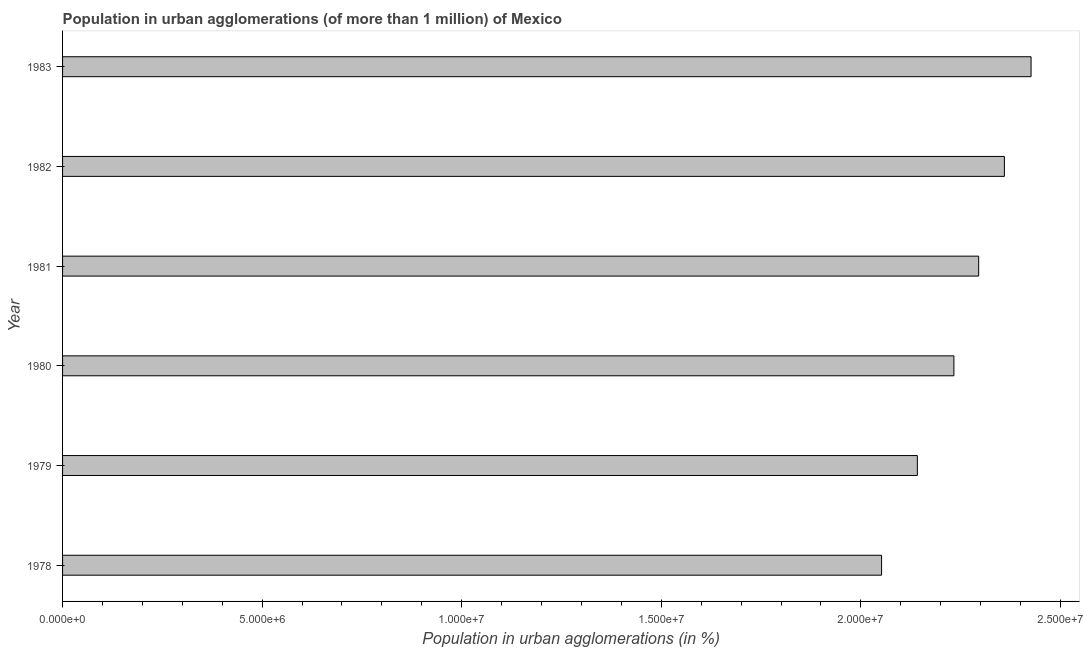Does the graph contain grids?
Make the answer very short. No. What is the title of the graph?
Your answer should be compact. Population in urban agglomerations (of more than 1 million) of Mexico. What is the label or title of the X-axis?
Your response must be concise. Population in urban agglomerations (in %). What is the population in urban agglomerations in 1978?
Your answer should be very brief. 2.05e+07. Across all years, what is the maximum population in urban agglomerations?
Give a very brief answer. 2.43e+07. Across all years, what is the minimum population in urban agglomerations?
Offer a very short reply. 2.05e+07. In which year was the population in urban agglomerations maximum?
Offer a very short reply. 1983. In which year was the population in urban agglomerations minimum?
Your answer should be compact. 1978. What is the sum of the population in urban agglomerations?
Keep it short and to the point. 1.35e+08. What is the difference between the population in urban agglomerations in 1979 and 1983?
Your answer should be compact. -2.85e+06. What is the average population in urban agglomerations per year?
Your answer should be very brief. 2.25e+07. What is the median population in urban agglomerations?
Provide a succinct answer. 2.26e+07. In how many years, is the population in urban agglomerations greater than 17000000 %?
Offer a terse response. 6. Do a majority of the years between 1983 and 1981 (inclusive) have population in urban agglomerations greater than 1000000 %?
Provide a short and direct response. Yes. What is the ratio of the population in urban agglomerations in 1981 to that in 1982?
Keep it short and to the point. 0.97. Is the difference between the population in urban agglomerations in 1978 and 1980 greater than the difference between any two years?
Ensure brevity in your answer.  No. What is the difference between the highest and the second highest population in urban agglomerations?
Your response must be concise. 6.68e+05. What is the difference between the highest and the lowest population in urban agglomerations?
Ensure brevity in your answer.  3.75e+06. How many bars are there?
Your answer should be compact. 6. Are all the bars in the graph horizontal?
Keep it short and to the point. Yes. How many years are there in the graph?
Provide a succinct answer. 6. What is the difference between two consecutive major ticks on the X-axis?
Your answer should be very brief. 5.00e+06. What is the Population in urban agglomerations (in %) of 1978?
Offer a terse response. 2.05e+07. What is the Population in urban agglomerations (in %) of 1979?
Your answer should be very brief. 2.14e+07. What is the Population in urban agglomerations (in %) in 1980?
Provide a short and direct response. 2.23e+07. What is the Population in urban agglomerations (in %) of 1981?
Make the answer very short. 2.30e+07. What is the Population in urban agglomerations (in %) of 1982?
Your answer should be compact. 2.36e+07. What is the Population in urban agglomerations (in %) of 1983?
Your response must be concise. 2.43e+07. What is the difference between the Population in urban agglomerations (in %) in 1978 and 1979?
Make the answer very short. -8.96e+05. What is the difference between the Population in urban agglomerations (in %) in 1978 and 1980?
Give a very brief answer. -1.81e+06. What is the difference between the Population in urban agglomerations (in %) in 1978 and 1981?
Offer a very short reply. -2.43e+06. What is the difference between the Population in urban agglomerations (in %) in 1978 and 1982?
Offer a very short reply. -3.08e+06. What is the difference between the Population in urban agglomerations (in %) in 1978 and 1983?
Your answer should be very brief. -3.75e+06. What is the difference between the Population in urban agglomerations (in %) in 1979 and 1980?
Provide a short and direct response. -9.15e+05. What is the difference between the Population in urban agglomerations (in %) in 1979 and 1981?
Your answer should be compact. -1.54e+06. What is the difference between the Population in urban agglomerations (in %) in 1979 and 1982?
Your answer should be compact. -2.18e+06. What is the difference between the Population in urban agglomerations (in %) in 1979 and 1983?
Keep it short and to the point. -2.85e+06. What is the difference between the Population in urban agglomerations (in %) in 1980 and 1981?
Offer a terse response. -6.21e+05. What is the difference between the Population in urban agglomerations (in %) in 1980 and 1982?
Ensure brevity in your answer.  -1.27e+06. What is the difference between the Population in urban agglomerations (in %) in 1980 and 1983?
Ensure brevity in your answer.  -1.93e+06. What is the difference between the Population in urban agglomerations (in %) in 1981 and 1982?
Offer a terse response. -6.44e+05. What is the difference between the Population in urban agglomerations (in %) in 1981 and 1983?
Provide a short and direct response. -1.31e+06. What is the difference between the Population in urban agglomerations (in %) in 1982 and 1983?
Your answer should be compact. -6.68e+05. What is the ratio of the Population in urban agglomerations (in %) in 1978 to that in 1979?
Offer a terse response. 0.96. What is the ratio of the Population in urban agglomerations (in %) in 1978 to that in 1980?
Your response must be concise. 0.92. What is the ratio of the Population in urban agglomerations (in %) in 1978 to that in 1981?
Offer a terse response. 0.89. What is the ratio of the Population in urban agglomerations (in %) in 1978 to that in 1982?
Your answer should be very brief. 0.87. What is the ratio of the Population in urban agglomerations (in %) in 1978 to that in 1983?
Give a very brief answer. 0.85. What is the ratio of the Population in urban agglomerations (in %) in 1979 to that in 1980?
Provide a short and direct response. 0.96. What is the ratio of the Population in urban agglomerations (in %) in 1979 to that in 1981?
Your answer should be compact. 0.93. What is the ratio of the Population in urban agglomerations (in %) in 1979 to that in 1982?
Your answer should be compact. 0.91. What is the ratio of the Population in urban agglomerations (in %) in 1979 to that in 1983?
Provide a short and direct response. 0.88. What is the ratio of the Population in urban agglomerations (in %) in 1980 to that in 1981?
Make the answer very short. 0.97. What is the ratio of the Population in urban agglomerations (in %) in 1980 to that in 1982?
Offer a very short reply. 0.95. What is the ratio of the Population in urban agglomerations (in %) in 1981 to that in 1982?
Offer a very short reply. 0.97. What is the ratio of the Population in urban agglomerations (in %) in 1981 to that in 1983?
Your answer should be very brief. 0.95. 